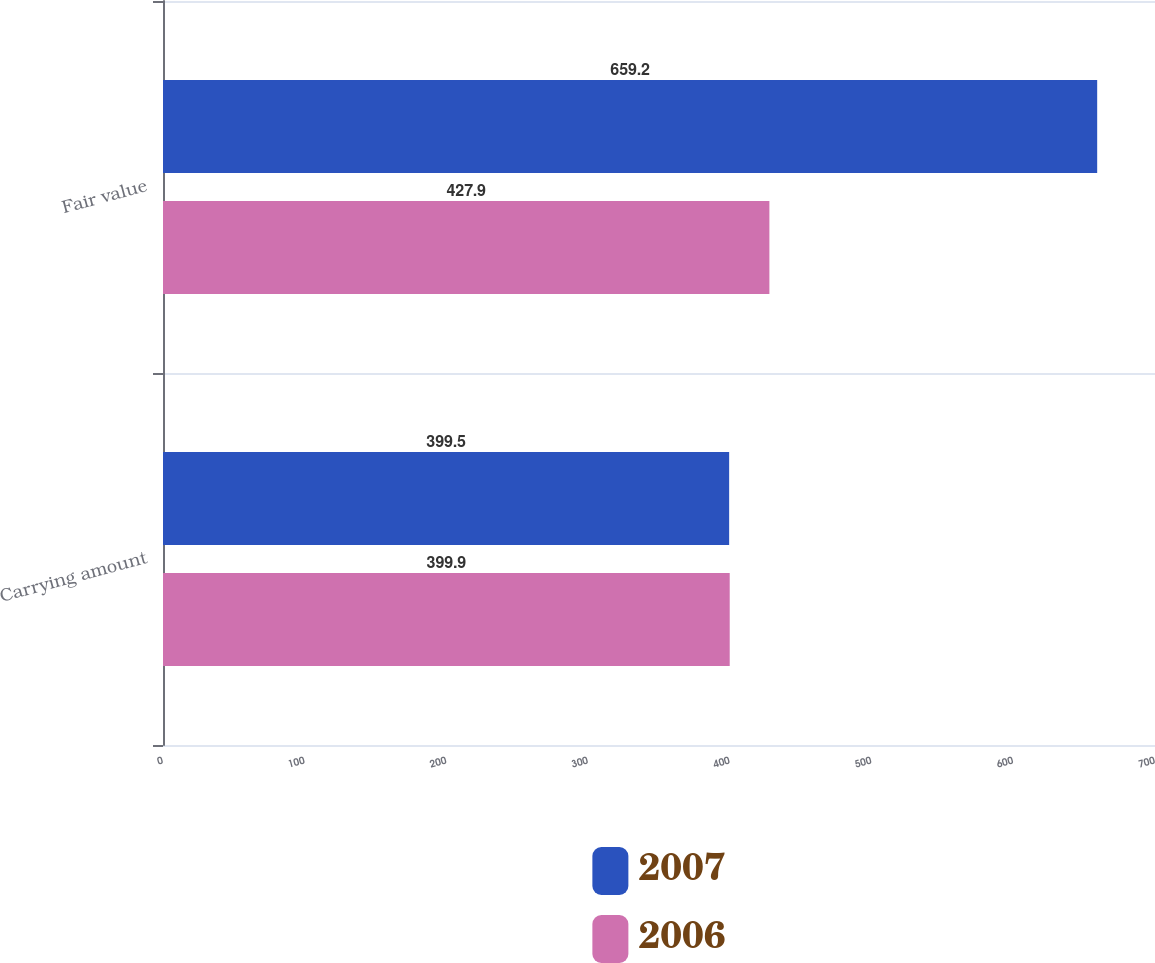Convert chart. <chart><loc_0><loc_0><loc_500><loc_500><stacked_bar_chart><ecel><fcel>Carrying amount<fcel>Fair value<nl><fcel>2007<fcel>399.5<fcel>659.2<nl><fcel>2006<fcel>399.9<fcel>427.9<nl></chart> 